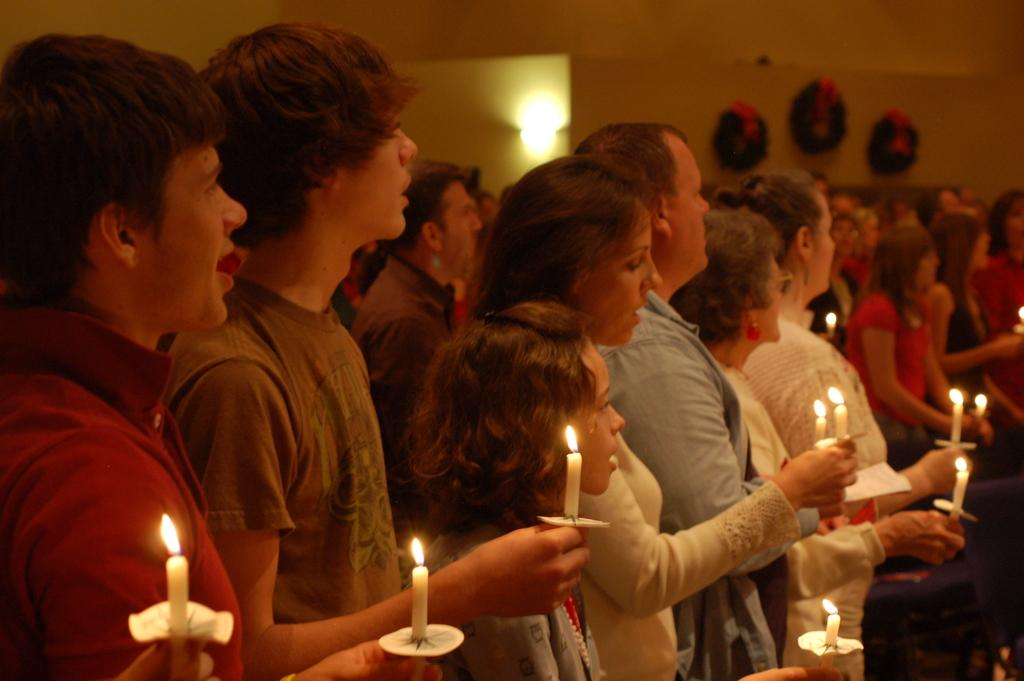How many people are in the room? The number of people in the room is not specified, but there are people present. What are some of the people holding? Some of the people are holding candles. What can be found on the wall in the room? There are objects attached to the wall. Where is the light located in the room? The light is on the roof. What type of sand can be seen on the road outside the room? There is no mention of sand or a road in the image, so it cannot be determined if there is sand on a road outside the room. 